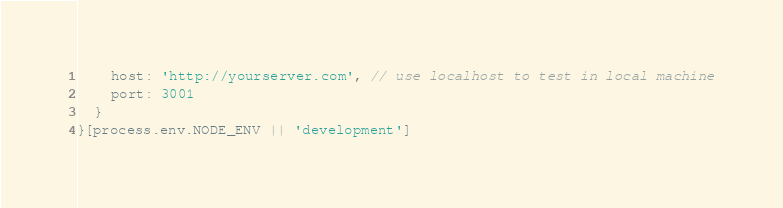Convert code to text. <code><loc_0><loc_0><loc_500><loc_500><_JavaScript_>    host: 'http://yourserver.com', // use localhost to test in local machine
    port: 3001
  }
}[process.env.NODE_ENV || 'development']
</code> 